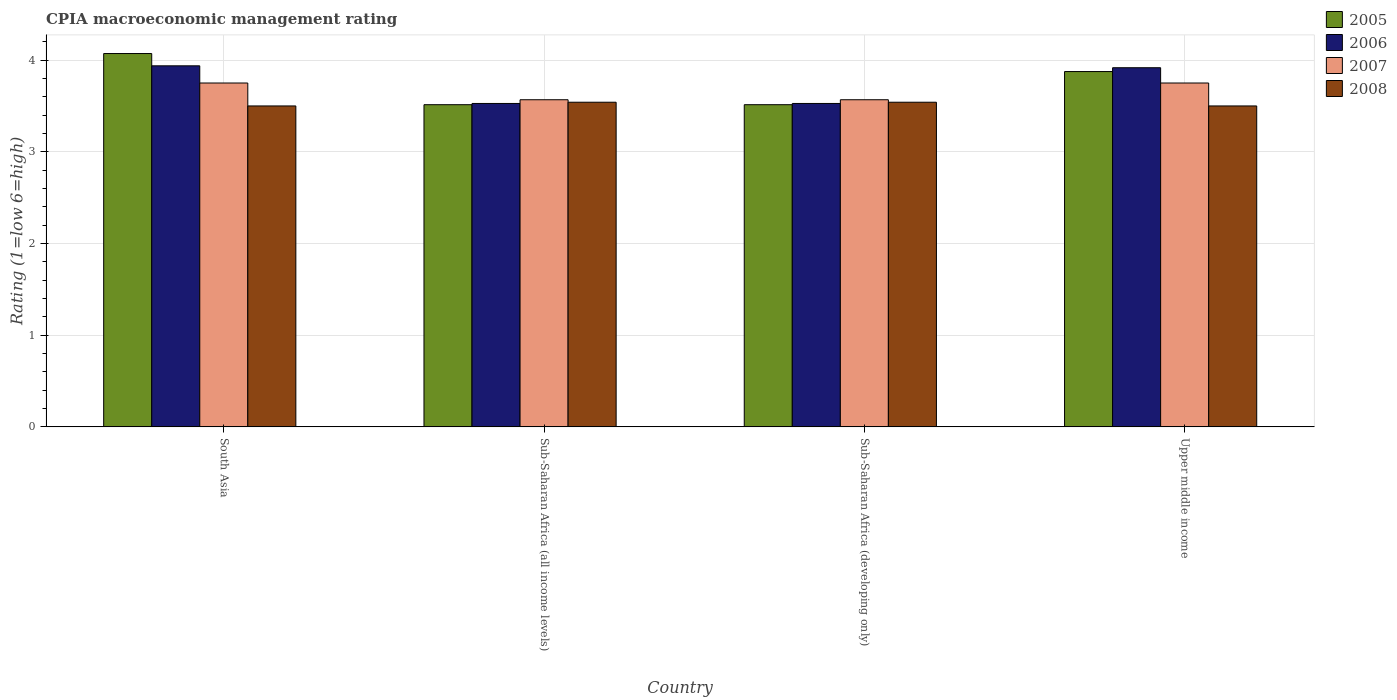How many groups of bars are there?
Offer a terse response. 4. Are the number of bars on each tick of the X-axis equal?
Offer a very short reply. Yes. How many bars are there on the 4th tick from the left?
Give a very brief answer. 4. How many bars are there on the 3rd tick from the right?
Give a very brief answer. 4. In how many cases, is the number of bars for a given country not equal to the number of legend labels?
Provide a succinct answer. 0. What is the CPIA rating in 2005 in Sub-Saharan Africa (developing only)?
Keep it short and to the point. 3.51. Across all countries, what is the maximum CPIA rating in 2005?
Ensure brevity in your answer.  4.07. Across all countries, what is the minimum CPIA rating in 2007?
Keep it short and to the point. 3.57. In which country was the CPIA rating in 2007 maximum?
Keep it short and to the point. South Asia. What is the total CPIA rating in 2007 in the graph?
Offer a terse response. 14.64. What is the difference between the CPIA rating in 2008 in Upper middle income and the CPIA rating in 2005 in Sub-Saharan Africa (all income levels)?
Your answer should be compact. -0.01. What is the average CPIA rating in 2006 per country?
Give a very brief answer. 3.73. What is the difference between the CPIA rating of/in 2008 and CPIA rating of/in 2005 in Sub-Saharan Africa (all income levels)?
Keep it short and to the point. 0.03. In how many countries, is the CPIA rating in 2005 greater than 2.6?
Keep it short and to the point. 4. What is the ratio of the CPIA rating in 2007 in South Asia to that in Upper middle income?
Give a very brief answer. 1. Is the CPIA rating in 2008 in Sub-Saharan Africa (all income levels) less than that in Sub-Saharan Africa (developing only)?
Your answer should be very brief. No. What is the difference between the highest and the second highest CPIA rating in 2006?
Your answer should be compact. -0.02. What is the difference between the highest and the lowest CPIA rating in 2008?
Provide a succinct answer. 0.04. Is the sum of the CPIA rating in 2007 in Sub-Saharan Africa (all income levels) and Upper middle income greater than the maximum CPIA rating in 2008 across all countries?
Ensure brevity in your answer.  Yes. Is it the case that in every country, the sum of the CPIA rating in 2006 and CPIA rating in 2007 is greater than the sum of CPIA rating in 2005 and CPIA rating in 2008?
Make the answer very short. Yes. What does the 4th bar from the right in Upper middle income represents?
Ensure brevity in your answer.  2005. Is it the case that in every country, the sum of the CPIA rating in 2008 and CPIA rating in 2005 is greater than the CPIA rating in 2007?
Ensure brevity in your answer.  Yes. How many bars are there?
Make the answer very short. 16. How many countries are there in the graph?
Ensure brevity in your answer.  4. How many legend labels are there?
Your response must be concise. 4. How are the legend labels stacked?
Keep it short and to the point. Vertical. What is the title of the graph?
Give a very brief answer. CPIA macroeconomic management rating. Does "1975" appear as one of the legend labels in the graph?
Ensure brevity in your answer.  No. What is the label or title of the X-axis?
Provide a succinct answer. Country. What is the label or title of the Y-axis?
Offer a terse response. Rating (1=low 6=high). What is the Rating (1=low 6=high) of 2005 in South Asia?
Provide a succinct answer. 4.07. What is the Rating (1=low 6=high) of 2006 in South Asia?
Your answer should be very brief. 3.94. What is the Rating (1=low 6=high) of 2007 in South Asia?
Provide a short and direct response. 3.75. What is the Rating (1=low 6=high) of 2008 in South Asia?
Offer a very short reply. 3.5. What is the Rating (1=low 6=high) in 2005 in Sub-Saharan Africa (all income levels)?
Keep it short and to the point. 3.51. What is the Rating (1=low 6=high) of 2006 in Sub-Saharan Africa (all income levels)?
Provide a succinct answer. 3.53. What is the Rating (1=low 6=high) in 2007 in Sub-Saharan Africa (all income levels)?
Your answer should be compact. 3.57. What is the Rating (1=low 6=high) of 2008 in Sub-Saharan Africa (all income levels)?
Ensure brevity in your answer.  3.54. What is the Rating (1=low 6=high) of 2005 in Sub-Saharan Africa (developing only)?
Provide a short and direct response. 3.51. What is the Rating (1=low 6=high) of 2006 in Sub-Saharan Africa (developing only)?
Offer a very short reply. 3.53. What is the Rating (1=low 6=high) of 2007 in Sub-Saharan Africa (developing only)?
Offer a very short reply. 3.57. What is the Rating (1=low 6=high) of 2008 in Sub-Saharan Africa (developing only)?
Provide a short and direct response. 3.54. What is the Rating (1=low 6=high) in 2005 in Upper middle income?
Your response must be concise. 3.88. What is the Rating (1=low 6=high) of 2006 in Upper middle income?
Offer a terse response. 3.92. What is the Rating (1=low 6=high) of 2007 in Upper middle income?
Your response must be concise. 3.75. What is the Rating (1=low 6=high) in 2008 in Upper middle income?
Ensure brevity in your answer.  3.5. Across all countries, what is the maximum Rating (1=low 6=high) of 2005?
Your answer should be very brief. 4.07. Across all countries, what is the maximum Rating (1=low 6=high) of 2006?
Ensure brevity in your answer.  3.94. Across all countries, what is the maximum Rating (1=low 6=high) in 2007?
Your answer should be compact. 3.75. Across all countries, what is the maximum Rating (1=low 6=high) of 2008?
Keep it short and to the point. 3.54. Across all countries, what is the minimum Rating (1=low 6=high) of 2005?
Your answer should be compact. 3.51. Across all countries, what is the minimum Rating (1=low 6=high) in 2006?
Provide a succinct answer. 3.53. Across all countries, what is the minimum Rating (1=low 6=high) in 2007?
Ensure brevity in your answer.  3.57. What is the total Rating (1=low 6=high) in 2005 in the graph?
Provide a succinct answer. 14.97. What is the total Rating (1=low 6=high) of 2006 in the graph?
Ensure brevity in your answer.  14.91. What is the total Rating (1=low 6=high) in 2007 in the graph?
Keep it short and to the point. 14.64. What is the total Rating (1=low 6=high) of 2008 in the graph?
Make the answer very short. 14.08. What is the difference between the Rating (1=low 6=high) in 2005 in South Asia and that in Sub-Saharan Africa (all income levels)?
Your answer should be very brief. 0.56. What is the difference between the Rating (1=low 6=high) in 2006 in South Asia and that in Sub-Saharan Africa (all income levels)?
Ensure brevity in your answer.  0.41. What is the difference between the Rating (1=low 6=high) of 2007 in South Asia and that in Sub-Saharan Africa (all income levels)?
Your answer should be very brief. 0.18. What is the difference between the Rating (1=low 6=high) of 2008 in South Asia and that in Sub-Saharan Africa (all income levels)?
Offer a terse response. -0.04. What is the difference between the Rating (1=low 6=high) of 2005 in South Asia and that in Sub-Saharan Africa (developing only)?
Give a very brief answer. 0.56. What is the difference between the Rating (1=low 6=high) in 2006 in South Asia and that in Sub-Saharan Africa (developing only)?
Offer a terse response. 0.41. What is the difference between the Rating (1=low 6=high) in 2007 in South Asia and that in Sub-Saharan Africa (developing only)?
Give a very brief answer. 0.18. What is the difference between the Rating (1=low 6=high) of 2008 in South Asia and that in Sub-Saharan Africa (developing only)?
Offer a very short reply. -0.04. What is the difference between the Rating (1=low 6=high) of 2005 in South Asia and that in Upper middle income?
Your answer should be compact. 0.2. What is the difference between the Rating (1=low 6=high) in 2006 in South Asia and that in Upper middle income?
Ensure brevity in your answer.  0.02. What is the difference between the Rating (1=low 6=high) of 2005 in Sub-Saharan Africa (all income levels) and that in Sub-Saharan Africa (developing only)?
Keep it short and to the point. 0. What is the difference between the Rating (1=low 6=high) in 2007 in Sub-Saharan Africa (all income levels) and that in Sub-Saharan Africa (developing only)?
Your answer should be very brief. 0. What is the difference between the Rating (1=low 6=high) in 2008 in Sub-Saharan Africa (all income levels) and that in Sub-Saharan Africa (developing only)?
Your answer should be compact. 0. What is the difference between the Rating (1=low 6=high) of 2005 in Sub-Saharan Africa (all income levels) and that in Upper middle income?
Offer a very short reply. -0.36. What is the difference between the Rating (1=low 6=high) of 2006 in Sub-Saharan Africa (all income levels) and that in Upper middle income?
Your response must be concise. -0.39. What is the difference between the Rating (1=low 6=high) in 2007 in Sub-Saharan Africa (all income levels) and that in Upper middle income?
Ensure brevity in your answer.  -0.18. What is the difference between the Rating (1=low 6=high) in 2008 in Sub-Saharan Africa (all income levels) and that in Upper middle income?
Your response must be concise. 0.04. What is the difference between the Rating (1=low 6=high) of 2005 in Sub-Saharan Africa (developing only) and that in Upper middle income?
Give a very brief answer. -0.36. What is the difference between the Rating (1=low 6=high) of 2006 in Sub-Saharan Africa (developing only) and that in Upper middle income?
Provide a succinct answer. -0.39. What is the difference between the Rating (1=low 6=high) in 2007 in Sub-Saharan Africa (developing only) and that in Upper middle income?
Provide a short and direct response. -0.18. What is the difference between the Rating (1=low 6=high) of 2008 in Sub-Saharan Africa (developing only) and that in Upper middle income?
Provide a succinct answer. 0.04. What is the difference between the Rating (1=low 6=high) of 2005 in South Asia and the Rating (1=low 6=high) of 2006 in Sub-Saharan Africa (all income levels)?
Provide a succinct answer. 0.54. What is the difference between the Rating (1=low 6=high) in 2005 in South Asia and the Rating (1=low 6=high) in 2007 in Sub-Saharan Africa (all income levels)?
Offer a very short reply. 0.5. What is the difference between the Rating (1=low 6=high) of 2005 in South Asia and the Rating (1=low 6=high) of 2008 in Sub-Saharan Africa (all income levels)?
Provide a succinct answer. 0.53. What is the difference between the Rating (1=low 6=high) in 2006 in South Asia and the Rating (1=low 6=high) in 2007 in Sub-Saharan Africa (all income levels)?
Your answer should be very brief. 0.37. What is the difference between the Rating (1=low 6=high) in 2006 in South Asia and the Rating (1=low 6=high) in 2008 in Sub-Saharan Africa (all income levels)?
Ensure brevity in your answer.  0.4. What is the difference between the Rating (1=low 6=high) in 2007 in South Asia and the Rating (1=low 6=high) in 2008 in Sub-Saharan Africa (all income levels)?
Make the answer very short. 0.21. What is the difference between the Rating (1=low 6=high) in 2005 in South Asia and the Rating (1=low 6=high) in 2006 in Sub-Saharan Africa (developing only)?
Your response must be concise. 0.54. What is the difference between the Rating (1=low 6=high) in 2005 in South Asia and the Rating (1=low 6=high) in 2007 in Sub-Saharan Africa (developing only)?
Provide a succinct answer. 0.5. What is the difference between the Rating (1=low 6=high) of 2005 in South Asia and the Rating (1=low 6=high) of 2008 in Sub-Saharan Africa (developing only)?
Your response must be concise. 0.53. What is the difference between the Rating (1=low 6=high) of 2006 in South Asia and the Rating (1=low 6=high) of 2007 in Sub-Saharan Africa (developing only)?
Offer a very short reply. 0.37. What is the difference between the Rating (1=low 6=high) of 2006 in South Asia and the Rating (1=low 6=high) of 2008 in Sub-Saharan Africa (developing only)?
Your answer should be very brief. 0.4. What is the difference between the Rating (1=low 6=high) of 2007 in South Asia and the Rating (1=low 6=high) of 2008 in Sub-Saharan Africa (developing only)?
Provide a short and direct response. 0.21. What is the difference between the Rating (1=low 6=high) of 2005 in South Asia and the Rating (1=low 6=high) of 2006 in Upper middle income?
Ensure brevity in your answer.  0.15. What is the difference between the Rating (1=low 6=high) in 2005 in South Asia and the Rating (1=low 6=high) in 2007 in Upper middle income?
Your answer should be compact. 0.32. What is the difference between the Rating (1=low 6=high) of 2006 in South Asia and the Rating (1=low 6=high) of 2007 in Upper middle income?
Make the answer very short. 0.19. What is the difference between the Rating (1=low 6=high) in 2006 in South Asia and the Rating (1=low 6=high) in 2008 in Upper middle income?
Make the answer very short. 0.44. What is the difference between the Rating (1=low 6=high) in 2005 in Sub-Saharan Africa (all income levels) and the Rating (1=low 6=high) in 2006 in Sub-Saharan Africa (developing only)?
Give a very brief answer. -0.01. What is the difference between the Rating (1=low 6=high) of 2005 in Sub-Saharan Africa (all income levels) and the Rating (1=low 6=high) of 2007 in Sub-Saharan Africa (developing only)?
Make the answer very short. -0.05. What is the difference between the Rating (1=low 6=high) of 2005 in Sub-Saharan Africa (all income levels) and the Rating (1=low 6=high) of 2008 in Sub-Saharan Africa (developing only)?
Provide a short and direct response. -0.03. What is the difference between the Rating (1=low 6=high) of 2006 in Sub-Saharan Africa (all income levels) and the Rating (1=low 6=high) of 2007 in Sub-Saharan Africa (developing only)?
Your answer should be compact. -0.04. What is the difference between the Rating (1=low 6=high) of 2006 in Sub-Saharan Africa (all income levels) and the Rating (1=low 6=high) of 2008 in Sub-Saharan Africa (developing only)?
Give a very brief answer. -0.01. What is the difference between the Rating (1=low 6=high) in 2007 in Sub-Saharan Africa (all income levels) and the Rating (1=low 6=high) in 2008 in Sub-Saharan Africa (developing only)?
Make the answer very short. 0.03. What is the difference between the Rating (1=low 6=high) in 2005 in Sub-Saharan Africa (all income levels) and the Rating (1=low 6=high) in 2006 in Upper middle income?
Provide a succinct answer. -0.4. What is the difference between the Rating (1=low 6=high) of 2005 in Sub-Saharan Africa (all income levels) and the Rating (1=low 6=high) of 2007 in Upper middle income?
Provide a short and direct response. -0.24. What is the difference between the Rating (1=low 6=high) in 2005 in Sub-Saharan Africa (all income levels) and the Rating (1=low 6=high) in 2008 in Upper middle income?
Provide a short and direct response. 0.01. What is the difference between the Rating (1=low 6=high) in 2006 in Sub-Saharan Africa (all income levels) and the Rating (1=low 6=high) in 2007 in Upper middle income?
Your answer should be compact. -0.22. What is the difference between the Rating (1=low 6=high) of 2006 in Sub-Saharan Africa (all income levels) and the Rating (1=low 6=high) of 2008 in Upper middle income?
Your answer should be compact. 0.03. What is the difference between the Rating (1=low 6=high) of 2007 in Sub-Saharan Africa (all income levels) and the Rating (1=low 6=high) of 2008 in Upper middle income?
Provide a short and direct response. 0.07. What is the difference between the Rating (1=low 6=high) of 2005 in Sub-Saharan Africa (developing only) and the Rating (1=low 6=high) of 2006 in Upper middle income?
Your response must be concise. -0.4. What is the difference between the Rating (1=low 6=high) of 2005 in Sub-Saharan Africa (developing only) and the Rating (1=low 6=high) of 2007 in Upper middle income?
Provide a short and direct response. -0.24. What is the difference between the Rating (1=low 6=high) of 2005 in Sub-Saharan Africa (developing only) and the Rating (1=low 6=high) of 2008 in Upper middle income?
Offer a very short reply. 0.01. What is the difference between the Rating (1=low 6=high) of 2006 in Sub-Saharan Africa (developing only) and the Rating (1=low 6=high) of 2007 in Upper middle income?
Your answer should be compact. -0.22. What is the difference between the Rating (1=low 6=high) in 2006 in Sub-Saharan Africa (developing only) and the Rating (1=low 6=high) in 2008 in Upper middle income?
Your response must be concise. 0.03. What is the difference between the Rating (1=low 6=high) in 2007 in Sub-Saharan Africa (developing only) and the Rating (1=low 6=high) in 2008 in Upper middle income?
Provide a succinct answer. 0.07. What is the average Rating (1=low 6=high) in 2005 per country?
Your answer should be compact. 3.74. What is the average Rating (1=low 6=high) of 2006 per country?
Ensure brevity in your answer.  3.73. What is the average Rating (1=low 6=high) in 2007 per country?
Provide a succinct answer. 3.66. What is the average Rating (1=low 6=high) in 2008 per country?
Give a very brief answer. 3.52. What is the difference between the Rating (1=low 6=high) in 2005 and Rating (1=low 6=high) in 2006 in South Asia?
Make the answer very short. 0.13. What is the difference between the Rating (1=low 6=high) in 2005 and Rating (1=low 6=high) in 2007 in South Asia?
Give a very brief answer. 0.32. What is the difference between the Rating (1=low 6=high) in 2006 and Rating (1=low 6=high) in 2007 in South Asia?
Provide a short and direct response. 0.19. What is the difference between the Rating (1=low 6=high) in 2006 and Rating (1=low 6=high) in 2008 in South Asia?
Your response must be concise. 0.44. What is the difference between the Rating (1=low 6=high) of 2005 and Rating (1=low 6=high) of 2006 in Sub-Saharan Africa (all income levels)?
Your answer should be very brief. -0.01. What is the difference between the Rating (1=low 6=high) in 2005 and Rating (1=low 6=high) in 2007 in Sub-Saharan Africa (all income levels)?
Your answer should be very brief. -0.05. What is the difference between the Rating (1=low 6=high) in 2005 and Rating (1=low 6=high) in 2008 in Sub-Saharan Africa (all income levels)?
Offer a very short reply. -0.03. What is the difference between the Rating (1=low 6=high) in 2006 and Rating (1=low 6=high) in 2007 in Sub-Saharan Africa (all income levels)?
Your answer should be very brief. -0.04. What is the difference between the Rating (1=low 6=high) in 2006 and Rating (1=low 6=high) in 2008 in Sub-Saharan Africa (all income levels)?
Ensure brevity in your answer.  -0.01. What is the difference between the Rating (1=low 6=high) in 2007 and Rating (1=low 6=high) in 2008 in Sub-Saharan Africa (all income levels)?
Make the answer very short. 0.03. What is the difference between the Rating (1=low 6=high) of 2005 and Rating (1=low 6=high) of 2006 in Sub-Saharan Africa (developing only)?
Offer a very short reply. -0.01. What is the difference between the Rating (1=low 6=high) in 2005 and Rating (1=low 6=high) in 2007 in Sub-Saharan Africa (developing only)?
Your response must be concise. -0.05. What is the difference between the Rating (1=low 6=high) in 2005 and Rating (1=low 6=high) in 2008 in Sub-Saharan Africa (developing only)?
Keep it short and to the point. -0.03. What is the difference between the Rating (1=low 6=high) in 2006 and Rating (1=low 6=high) in 2007 in Sub-Saharan Africa (developing only)?
Ensure brevity in your answer.  -0.04. What is the difference between the Rating (1=low 6=high) in 2006 and Rating (1=low 6=high) in 2008 in Sub-Saharan Africa (developing only)?
Provide a succinct answer. -0.01. What is the difference between the Rating (1=low 6=high) in 2007 and Rating (1=low 6=high) in 2008 in Sub-Saharan Africa (developing only)?
Offer a terse response. 0.03. What is the difference between the Rating (1=low 6=high) in 2005 and Rating (1=low 6=high) in 2006 in Upper middle income?
Provide a succinct answer. -0.04. What is the difference between the Rating (1=low 6=high) in 2005 and Rating (1=low 6=high) in 2007 in Upper middle income?
Your answer should be compact. 0.12. What is the difference between the Rating (1=low 6=high) in 2006 and Rating (1=low 6=high) in 2007 in Upper middle income?
Give a very brief answer. 0.17. What is the difference between the Rating (1=low 6=high) of 2006 and Rating (1=low 6=high) of 2008 in Upper middle income?
Offer a terse response. 0.42. What is the ratio of the Rating (1=low 6=high) in 2005 in South Asia to that in Sub-Saharan Africa (all income levels)?
Keep it short and to the point. 1.16. What is the ratio of the Rating (1=low 6=high) of 2006 in South Asia to that in Sub-Saharan Africa (all income levels)?
Make the answer very short. 1.12. What is the ratio of the Rating (1=low 6=high) of 2007 in South Asia to that in Sub-Saharan Africa (all income levels)?
Your answer should be very brief. 1.05. What is the ratio of the Rating (1=low 6=high) in 2005 in South Asia to that in Sub-Saharan Africa (developing only)?
Offer a terse response. 1.16. What is the ratio of the Rating (1=low 6=high) of 2006 in South Asia to that in Sub-Saharan Africa (developing only)?
Offer a terse response. 1.12. What is the ratio of the Rating (1=low 6=high) of 2007 in South Asia to that in Sub-Saharan Africa (developing only)?
Provide a succinct answer. 1.05. What is the ratio of the Rating (1=low 6=high) of 2005 in South Asia to that in Upper middle income?
Your answer should be compact. 1.05. What is the ratio of the Rating (1=low 6=high) in 2006 in South Asia to that in Upper middle income?
Provide a succinct answer. 1.01. What is the ratio of the Rating (1=low 6=high) of 2007 in South Asia to that in Upper middle income?
Your answer should be very brief. 1. What is the ratio of the Rating (1=low 6=high) in 2008 in South Asia to that in Upper middle income?
Give a very brief answer. 1. What is the ratio of the Rating (1=low 6=high) in 2005 in Sub-Saharan Africa (all income levels) to that in Sub-Saharan Africa (developing only)?
Provide a succinct answer. 1. What is the ratio of the Rating (1=low 6=high) of 2005 in Sub-Saharan Africa (all income levels) to that in Upper middle income?
Give a very brief answer. 0.91. What is the ratio of the Rating (1=low 6=high) in 2006 in Sub-Saharan Africa (all income levels) to that in Upper middle income?
Make the answer very short. 0.9. What is the ratio of the Rating (1=low 6=high) in 2007 in Sub-Saharan Africa (all income levels) to that in Upper middle income?
Offer a very short reply. 0.95. What is the ratio of the Rating (1=low 6=high) in 2008 in Sub-Saharan Africa (all income levels) to that in Upper middle income?
Your response must be concise. 1.01. What is the ratio of the Rating (1=low 6=high) of 2005 in Sub-Saharan Africa (developing only) to that in Upper middle income?
Ensure brevity in your answer.  0.91. What is the ratio of the Rating (1=low 6=high) in 2006 in Sub-Saharan Africa (developing only) to that in Upper middle income?
Offer a very short reply. 0.9. What is the ratio of the Rating (1=low 6=high) in 2007 in Sub-Saharan Africa (developing only) to that in Upper middle income?
Make the answer very short. 0.95. What is the ratio of the Rating (1=low 6=high) of 2008 in Sub-Saharan Africa (developing only) to that in Upper middle income?
Offer a very short reply. 1.01. What is the difference between the highest and the second highest Rating (1=low 6=high) of 2005?
Provide a succinct answer. 0.2. What is the difference between the highest and the second highest Rating (1=low 6=high) of 2006?
Your answer should be compact. 0.02. What is the difference between the highest and the second highest Rating (1=low 6=high) of 2007?
Your response must be concise. 0. What is the difference between the highest and the lowest Rating (1=low 6=high) in 2005?
Offer a terse response. 0.56. What is the difference between the highest and the lowest Rating (1=low 6=high) in 2006?
Make the answer very short. 0.41. What is the difference between the highest and the lowest Rating (1=low 6=high) in 2007?
Keep it short and to the point. 0.18. What is the difference between the highest and the lowest Rating (1=low 6=high) of 2008?
Your response must be concise. 0.04. 